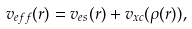Convert formula to latex. <formula><loc_0><loc_0><loc_500><loc_500>v _ { e f f } ( { r } ) = v _ { e s } ( { r } ) + v _ { x c } ( \rho ( { r } ) ) ,</formula> 